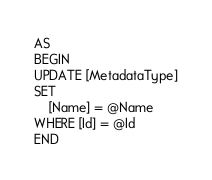Convert code to text. <code><loc_0><loc_0><loc_500><loc_500><_SQL_>AS
BEGIN
UPDATE [MetadataType]
SET
    [Name] = @Name
WHERE [Id] = @Id
END
</code> 